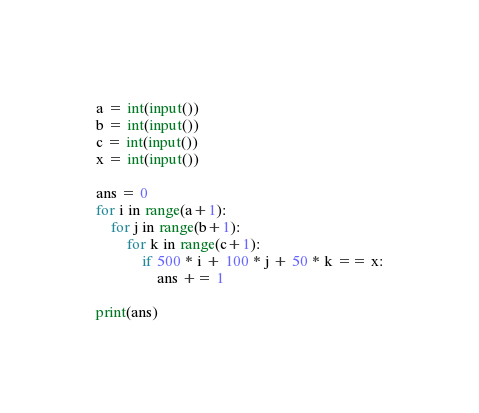Convert code to text. <code><loc_0><loc_0><loc_500><loc_500><_Python_>a = int(input())
b = int(input())
c = int(input())
x = int(input())

ans = 0
for i in range(a+1):
    for j in range(b+1):
        for k in range(c+1):
            if 500 * i + 100 * j + 50 * k == x:
                ans += 1

print(ans)
</code> 